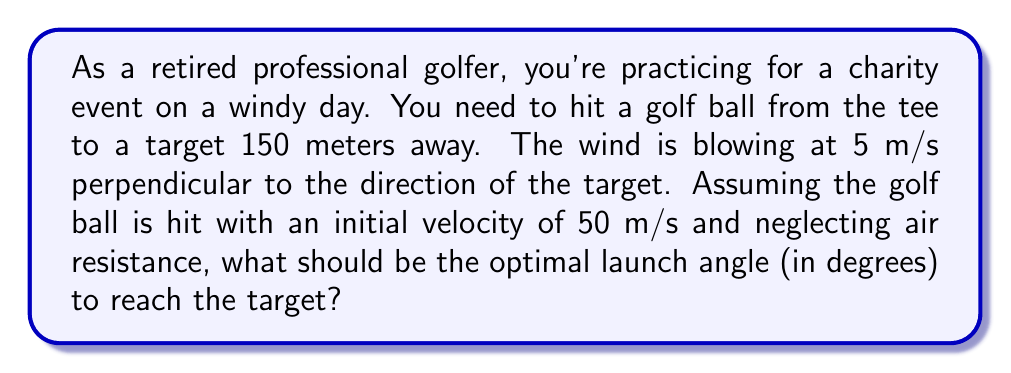Teach me how to tackle this problem. Let's approach this step-by-step:

1) In the absence of wind, we would use the standard projectile motion equations. However, the wind adds a constant velocity in the perpendicular direction.

2) Let's define our coordinate system:
   x-axis: direction towards the target
   y-axis: vertical direction
   z-axis: direction of the wind

3) The time of flight (t) is determined by the x-component of motion:
   $$150 = 50 \cos(\theta) \cdot t$$
   where $\theta$ is the launch angle.

4) The z-component of displacement due to wind is:
   $$z = 5t$$

5) For the ball to reach the target, the initial velocity in the z-direction must cancel out the wind effect:
   $$50 \sin(\theta) \sin(\phi) \cdot t = 5t$$
   where $\phi$ is the azimuthal angle in the x-z plane.

6) From steps 3 and 5:
   $$\sin(\theta) \sin(\phi) = \frac{5}{50} = 0.1$$

7) The optimal trajectory is when $\phi = 90°$ (perpendicular to the wind), so:
   $$\sin(\theta) = 0.1$$

8) Therefore:
   $$\theta = \arcsin(0.1) \approx 5.74°$$

This angle ensures that the ball reaches the target despite the wind.
Answer: 5.74° 